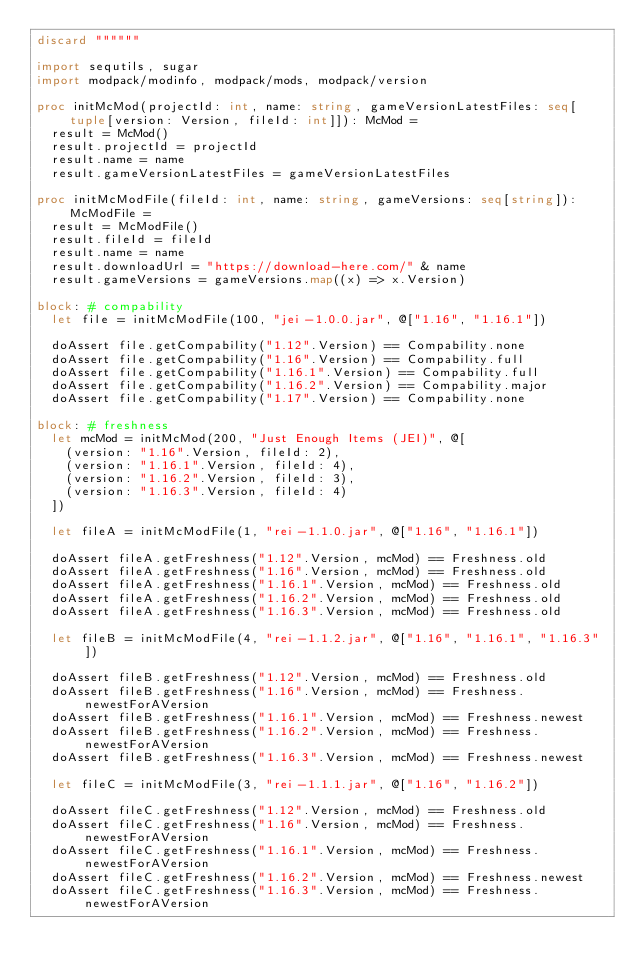<code> <loc_0><loc_0><loc_500><loc_500><_Nim_>discard """"""

import sequtils, sugar
import modpack/modinfo, modpack/mods, modpack/version

proc initMcMod(projectId: int, name: string, gameVersionLatestFiles: seq[tuple[version: Version, fileId: int]]): McMod =
  result = McMod()
  result.projectId = projectId
  result.name = name
  result.gameVersionLatestFiles = gameVersionLatestFiles

proc initMcModFile(fileId: int, name: string, gameVersions: seq[string]): McModFile =
  result = McModFile()
  result.fileId = fileId
  result.name = name
  result.downloadUrl = "https://download-here.com/" & name
  result.gameVersions = gameVersions.map((x) => x.Version)

block: # compability
  let file = initMcModFile(100, "jei-1.0.0.jar", @["1.16", "1.16.1"])
  
  doAssert file.getCompability("1.12".Version) == Compability.none
  doAssert file.getCompability("1.16".Version) == Compability.full
  doAssert file.getCompability("1.16.1".Version) == Compability.full
  doAssert file.getCompability("1.16.2".Version) == Compability.major
  doAssert file.getCompability("1.17".Version) == Compability.none

block: # freshness
  let mcMod = initMcMod(200, "Just Enough Items (JEI)", @[
    (version: "1.16".Version, fileId: 2),
    (version: "1.16.1".Version, fileId: 4),
    (version: "1.16.2".Version, fileId: 3),
    (version: "1.16.3".Version, fileId: 4)
  ])

  let fileA = initMcModFile(1, "rei-1.1.0.jar", @["1.16", "1.16.1"])

  doAssert fileA.getFreshness("1.12".Version, mcMod) == Freshness.old
  doAssert fileA.getFreshness("1.16".Version, mcMod) == Freshness.old
  doAssert fileA.getFreshness("1.16.1".Version, mcMod) == Freshness.old
  doAssert fileA.getFreshness("1.16.2".Version, mcMod) == Freshness.old
  doAssert fileA.getFreshness("1.16.3".Version, mcMod) == Freshness.old

  let fileB = initMcModFile(4, "rei-1.1.2.jar", @["1.16", "1.16.1", "1.16.3"])

  doAssert fileB.getFreshness("1.12".Version, mcMod) == Freshness.old
  doAssert fileB.getFreshness("1.16".Version, mcMod) == Freshness.newestForAVersion
  doAssert fileB.getFreshness("1.16.1".Version, mcMod) == Freshness.newest
  doAssert fileB.getFreshness("1.16.2".Version, mcMod) == Freshness.newestForAVersion
  doAssert fileB.getFreshness("1.16.3".Version, mcMod) == Freshness.newest

  let fileC = initMcModFile(3, "rei-1.1.1.jar", @["1.16", "1.16.2"])

  doAssert fileC.getFreshness("1.12".Version, mcMod) == Freshness.old
  doAssert fileC.getFreshness("1.16".Version, mcMod) == Freshness.newestForAVersion
  doAssert fileC.getFreshness("1.16.1".Version, mcMod) == Freshness.newestForAVersion
  doAssert fileC.getFreshness("1.16.2".Version, mcMod) == Freshness.newest
  doAssert fileC.getFreshness("1.16.3".Version, mcMod) == Freshness.newestForAVersion</code> 